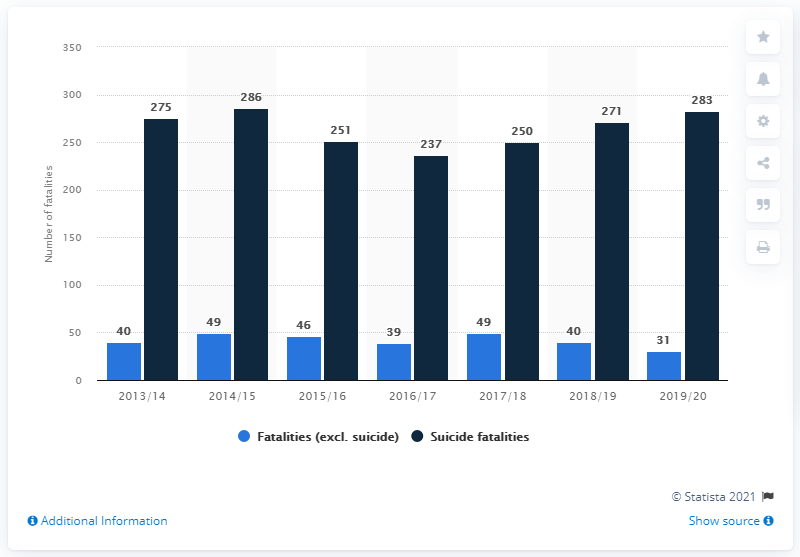Draw attention to some important aspects in this diagram. In the 2014/2015 fiscal year, 49 non-suicide deaths occurred. In the 2019/20 financial year, 283 suicides occurred on the British rail network. The number of non-suicide deaths that occurred on the British rail network during the 2019/20 financial year was 31. 